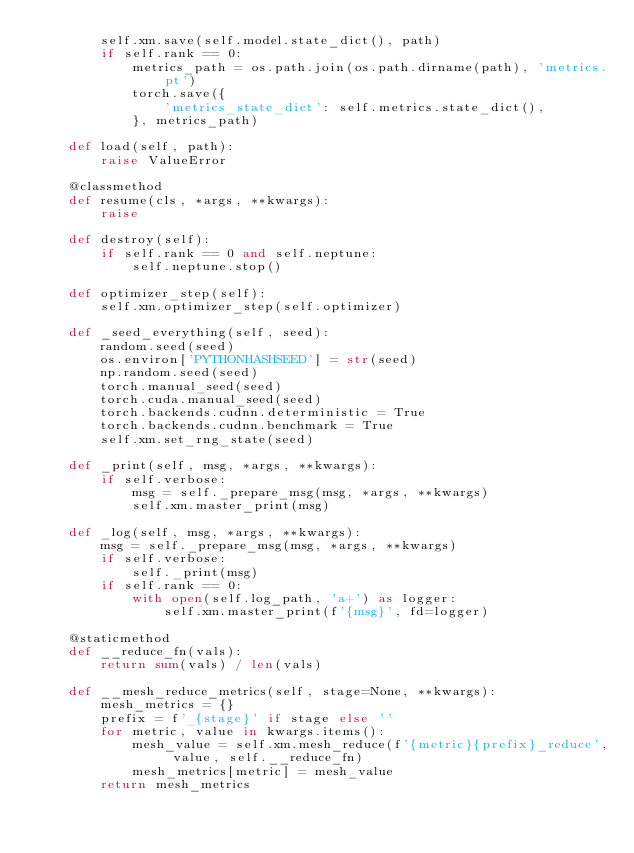<code> <loc_0><loc_0><loc_500><loc_500><_Python_>        self.xm.save(self.model.state_dict(), path)
        if self.rank == 0:
            metrics_path = os.path.join(os.path.dirname(path), 'metrics.pt')
            torch.save({
                'metrics_state_dict': self.metrics.state_dict(),
            }, metrics_path)

    def load(self, path):
        raise ValueError

    @classmethod
    def resume(cls, *args, **kwargs):
        raise

    def destroy(self):
        if self.rank == 0 and self.neptune:
            self.neptune.stop()

    def optimizer_step(self):
        self.xm.optimizer_step(self.optimizer)

    def _seed_everything(self, seed):
        random.seed(seed)
        os.environ['PYTHONHASHSEED'] = str(seed)
        np.random.seed(seed)
        torch.manual_seed(seed)
        torch.cuda.manual_seed(seed)
        torch.backends.cudnn.deterministic = True
        torch.backends.cudnn.benchmark = True
        self.xm.set_rng_state(seed)

    def _print(self, msg, *args, **kwargs):
        if self.verbose:
            msg = self._prepare_msg(msg, *args, **kwargs)
            self.xm.master_print(msg)

    def _log(self, msg, *args, **kwargs):
        msg = self._prepare_msg(msg, *args, **kwargs)
        if self.verbose:
            self._print(msg)
        if self.rank == 0:
            with open(self.log_path, 'a+') as logger:
                self.xm.master_print(f'{msg}', fd=logger)

    @staticmethod
    def __reduce_fn(vals):
        return sum(vals) / len(vals)

    def __mesh_reduce_metrics(self, stage=None, **kwargs):
        mesh_metrics = {}
        prefix = f'_{stage}' if stage else ''
        for metric, value in kwargs.items():
            mesh_value = self.xm.mesh_reduce(f'{metric}{prefix}_reduce', value, self.__reduce_fn)
            mesh_metrics[metric] = mesh_value
        return mesh_metrics
</code> 